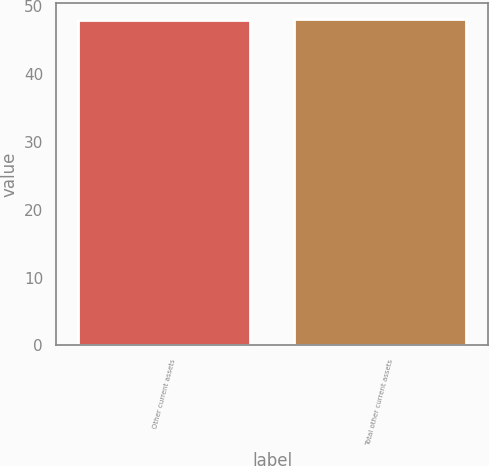Convert chart to OTSL. <chart><loc_0><loc_0><loc_500><loc_500><bar_chart><fcel>Other current assets<fcel>Total other current assets<nl><fcel>48<fcel>48.1<nl></chart> 